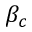<formula> <loc_0><loc_0><loc_500><loc_500>\beta _ { c }</formula> 